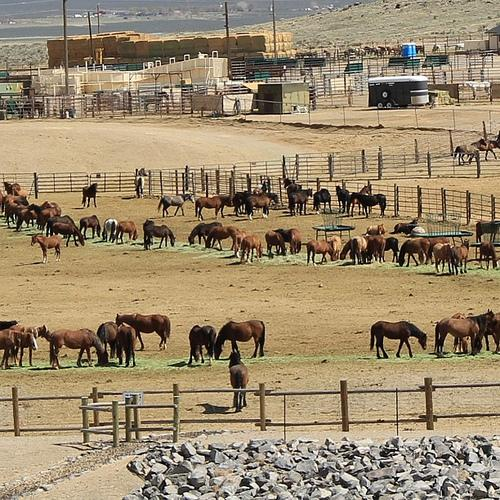Provide a brief description of the overall image. The image shows various horses in a pen, eating hay near fences and wooden posts, with a horse trailer, portable outhouses, and piles of rocks in the background. Count the total number of horses in the pen. There are at least nine horses in the pen. Identify the type and color of the trailer seen in the image. It is a green and white horse trailer. What are the horses doing in this image? The horses are eating hay and grass in the pen near the fences. Describe the type of fencing used in the pen and what kind of posts it has. The fencing in the pen is made of metal and wood, with wooden fence posts. Describe the landscape outside of the fenced-in pen. The landscape outside the pen features a field of rocks, with large stacks of hay and a brown hill in the background. Describe the main human-made structures in the image. The main human-made structures include metal and wooden fences, blue portable outhouses, wooden telephone poles, and a green and white horse trailer. What are the horses eating in the image? The horses are eating hay and green grass. How many portable toilets are there in the image and what color are they? There are two portable toilets in the image, and they are blue. Explain the purpose of the round container in the scene. The round container could potentially be a feeding station for the horses. Is there a big tree next to the hay stacks? No, it's not mentioned in the image. Can you find a yellow fence surrounding the horses? The fences described in the image are wooden and metal, with no mention of a yellow fence. Are there any orange portable toilets near the pen? The described portable toilets are blue, not orange. 